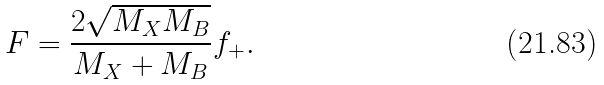Convert formula to latex. <formula><loc_0><loc_0><loc_500><loc_500>F = \frac { 2 \sqrt { M _ { X } M _ { B } } } { M _ { X } + M _ { B } } f _ { + } .</formula> 